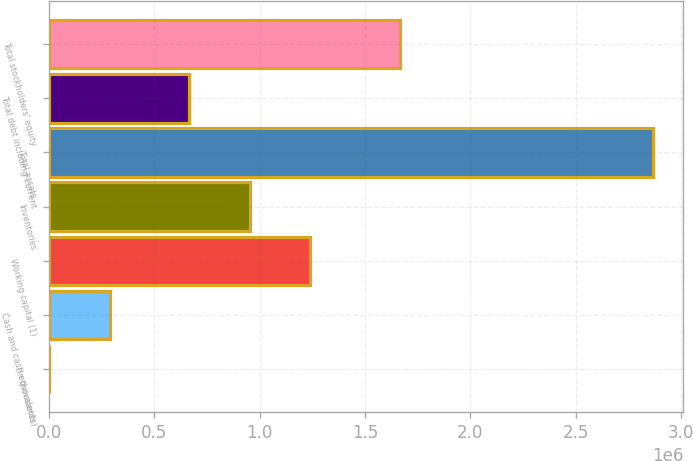Convert chart to OTSL. <chart><loc_0><loc_0><loc_500><loc_500><bar_chart><fcel>(In thousands)<fcel>Cash and cash equivalents<fcel>Working capital (1)<fcel>Inventories<fcel>Total assets<fcel>Total debt including current<fcel>Total stockholders' equity<nl><fcel>2015<fcel>288410<fcel>1.23886e+06<fcel>952466<fcel>2.86597e+06<fcel>666070<fcel>1.66822e+06<nl></chart> 